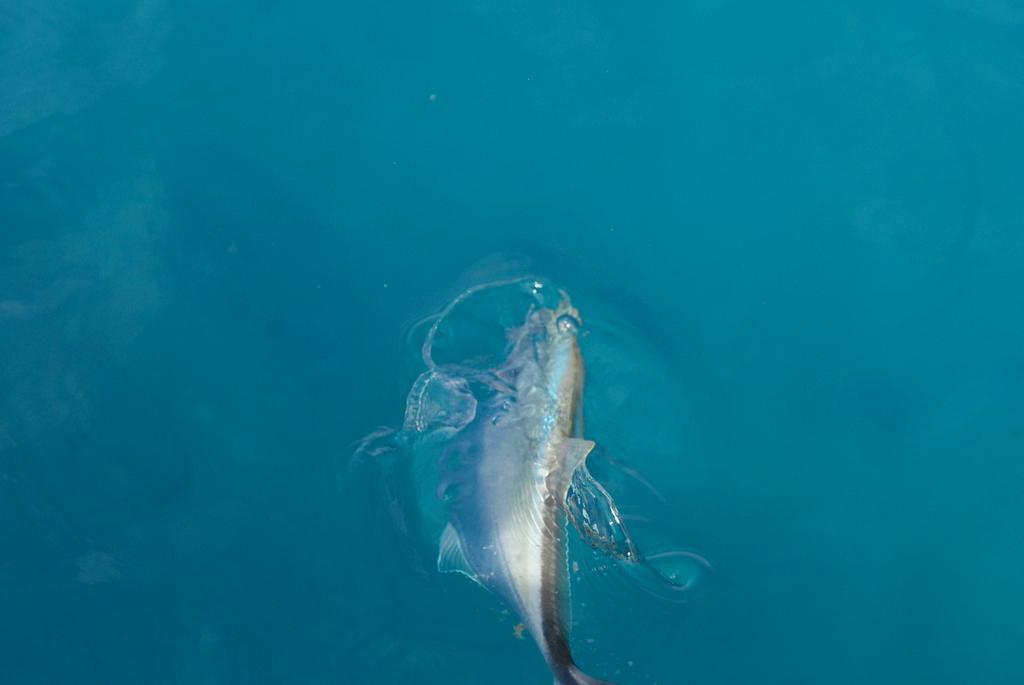Please provide a concise description of this image. In this picture we can see a fish in the water. 